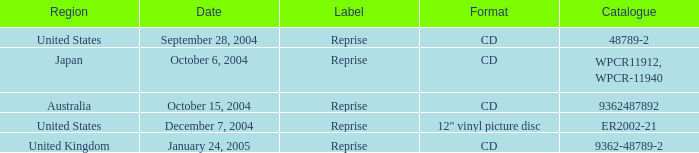What was the content of the catalog on october 15, 2004? 9362487892.0. 